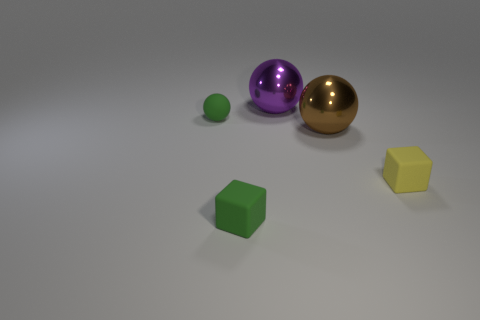Add 1 tiny objects. How many objects exist? 6 Subtract all gray spheres. Subtract all gray blocks. How many spheres are left? 3 Subtract all blocks. How many objects are left? 3 Add 1 green things. How many green things are left? 3 Add 4 green matte spheres. How many green matte spheres exist? 5 Subtract 1 green cubes. How many objects are left? 4 Subtract all big blue matte things. Subtract all brown metal balls. How many objects are left? 4 